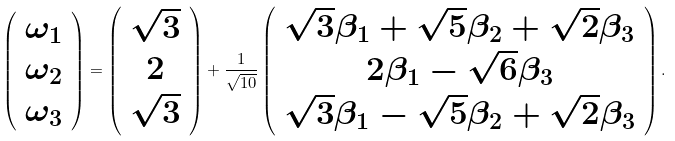Convert formula to latex. <formula><loc_0><loc_0><loc_500><loc_500>\left ( \begin{array} { c } \omega _ { 1 } \\ \omega _ { 2 } \\ \omega _ { 3 } \end{array} \right ) = \left ( \begin{array} { c } { \sqrt { 3 } } \\ 2 \\ { \sqrt { 3 } } \end{array} \right ) + \frac { 1 } { { \sqrt { 1 0 } } } \left ( \begin{array} { c } { \sqrt { 3 } } \beta _ { 1 } + { \sqrt { 5 } } \beta _ { 2 } + { \sqrt { 2 } } \beta _ { 3 } \\ 2 \beta _ { 1 } - { \sqrt { 6 } } \beta _ { 3 } \\ { \sqrt { 3 } } \beta _ { 1 } - { \sqrt { 5 } } \beta _ { 2 } + { \sqrt { 2 } } \beta _ { 3 } \end{array} \right ) .</formula> 